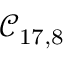<formula> <loc_0><loc_0><loc_500><loc_500>\mathcal { C } _ { 1 7 , 8 }</formula> 